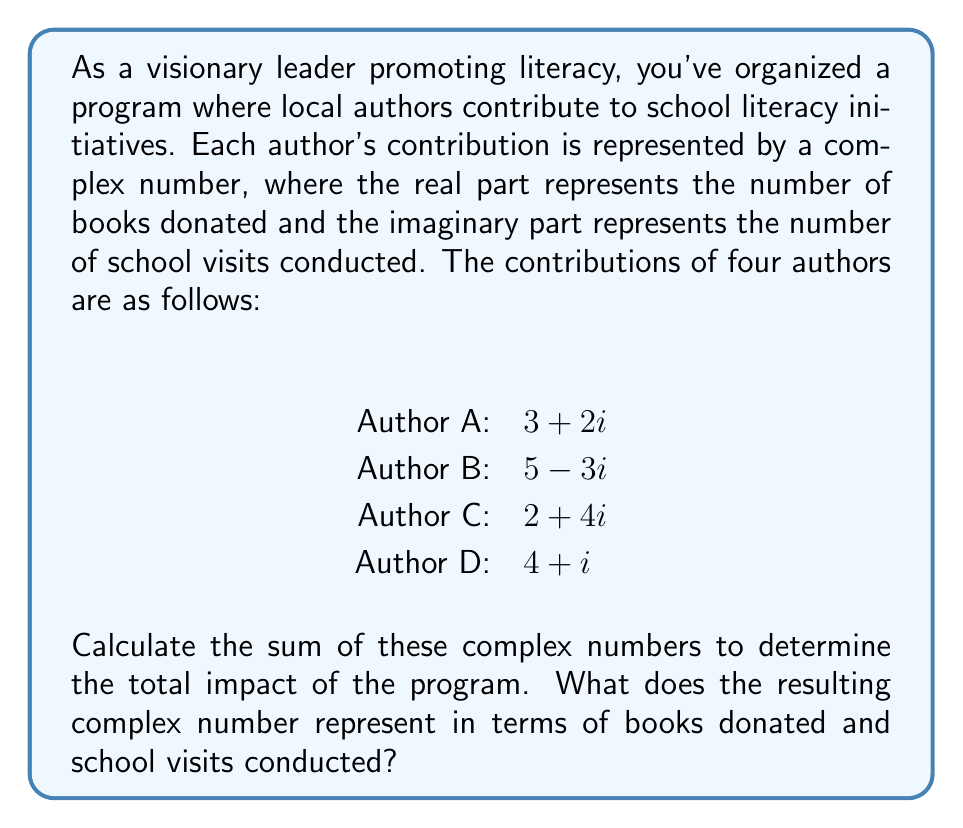Can you answer this question? To solve this problem, we need to add the complex numbers representing each author's contribution. Let's break it down step by step:

1) First, let's recall that to add complex numbers, we add the real parts and imaginary parts separately.

2) Let's list out our complex numbers:
   $z_1 = 3 + 2i$ (Author A)
   $z_2 = 5 - 3i$ (Author B)
   $z_3 = 2 + 4i$ (Author C)
   $z_4 = 4 + i$  (Author D)

3) Now, let's add these complex numbers:

   $$\begin{align}
   z_{total} &= z_1 + z_2 + z_3 + z_4 \\
   &= (3 + 2i) + (5 - 3i) + (2 + 4i) + (4 + i) \\
   &= (3 + 5 + 2 + 4) + (2 - 3 + 4 + 1)i \\
   &= 14 + 4i
   \end{align}$$

4) Interpreting the result:
   - The real part (14) represents the total number of books donated.
   - The imaginary part (4) represents the total number of school visits conducted.

Therefore, the total impact of the program is 14 books donated and 4 school visits conducted.
Answer: $14 + 4i$, representing 14 books donated and 4 school visits conducted. 